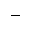<formula> <loc_0><loc_0><loc_500><loc_500>\_</formula> 